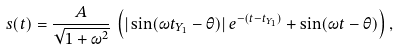<formula> <loc_0><loc_0><loc_500><loc_500>s ( t ) = \frac { A } { \sqrt { 1 + \omega ^ { 2 } } } \, \left ( | \sin ( \omega t _ { Y _ { 1 } } - \theta ) | \, e ^ { - ( t - t _ { Y _ { 1 } } ) } + \sin ( \omega t - \theta ) \right ) ,</formula> 